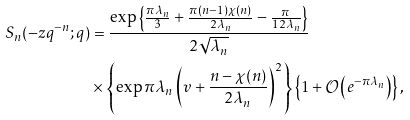Convert formula to latex. <formula><loc_0><loc_0><loc_500><loc_500>S _ { n } ( - z q ^ { - n } ; q ) & = \frac { \exp \left \{ \frac { \pi \lambda _ { n } } { 3 } + \frac { \pi ( n - 1 ) \chi ( n ) } { 2 \lambda _ { n } } - \frac { \pi } { 1 2 \lambda _ { n } } \right \} } { 2 \sqrt { \lambda _ { n } } } \\ & \times \left \{ \exp \pi \lambda _ { n } \left ( v + \frac { n - \chi ( n ) } { 2 \lambda _ { n } } \right ) ^ { 2 } \right \} \left \{ 1 + \mathcal { O } \left ( e ^ { - \pi \lambda _ { n } } \right ) \right \} ,</formula> 